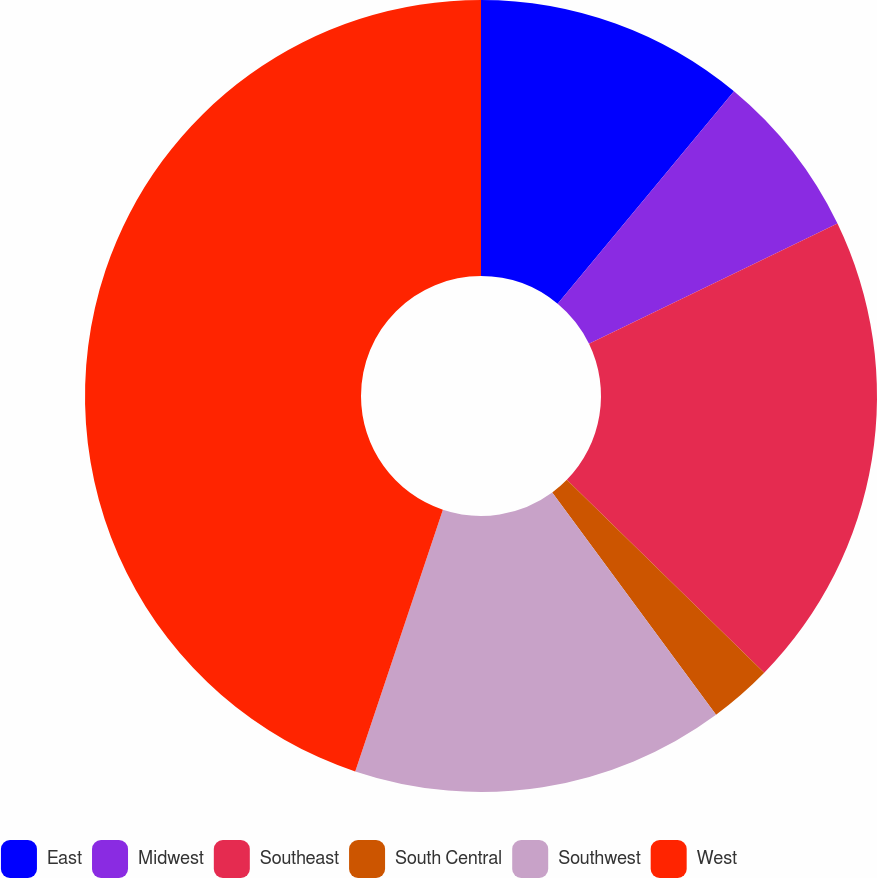<chart> <loc_0><loc_0><loc_500><loc_500><pie_chart><fcel>East<fcel>Midwest<fcel>Southeast<fcel>South Central<fcel>Southwest<fcel>West<nl><fcel>11.03%<fcel>6.8%<fcel>19.49%<fcel>2.57%<fcel>15.26%<fcel>44.86%<nl></chart> 